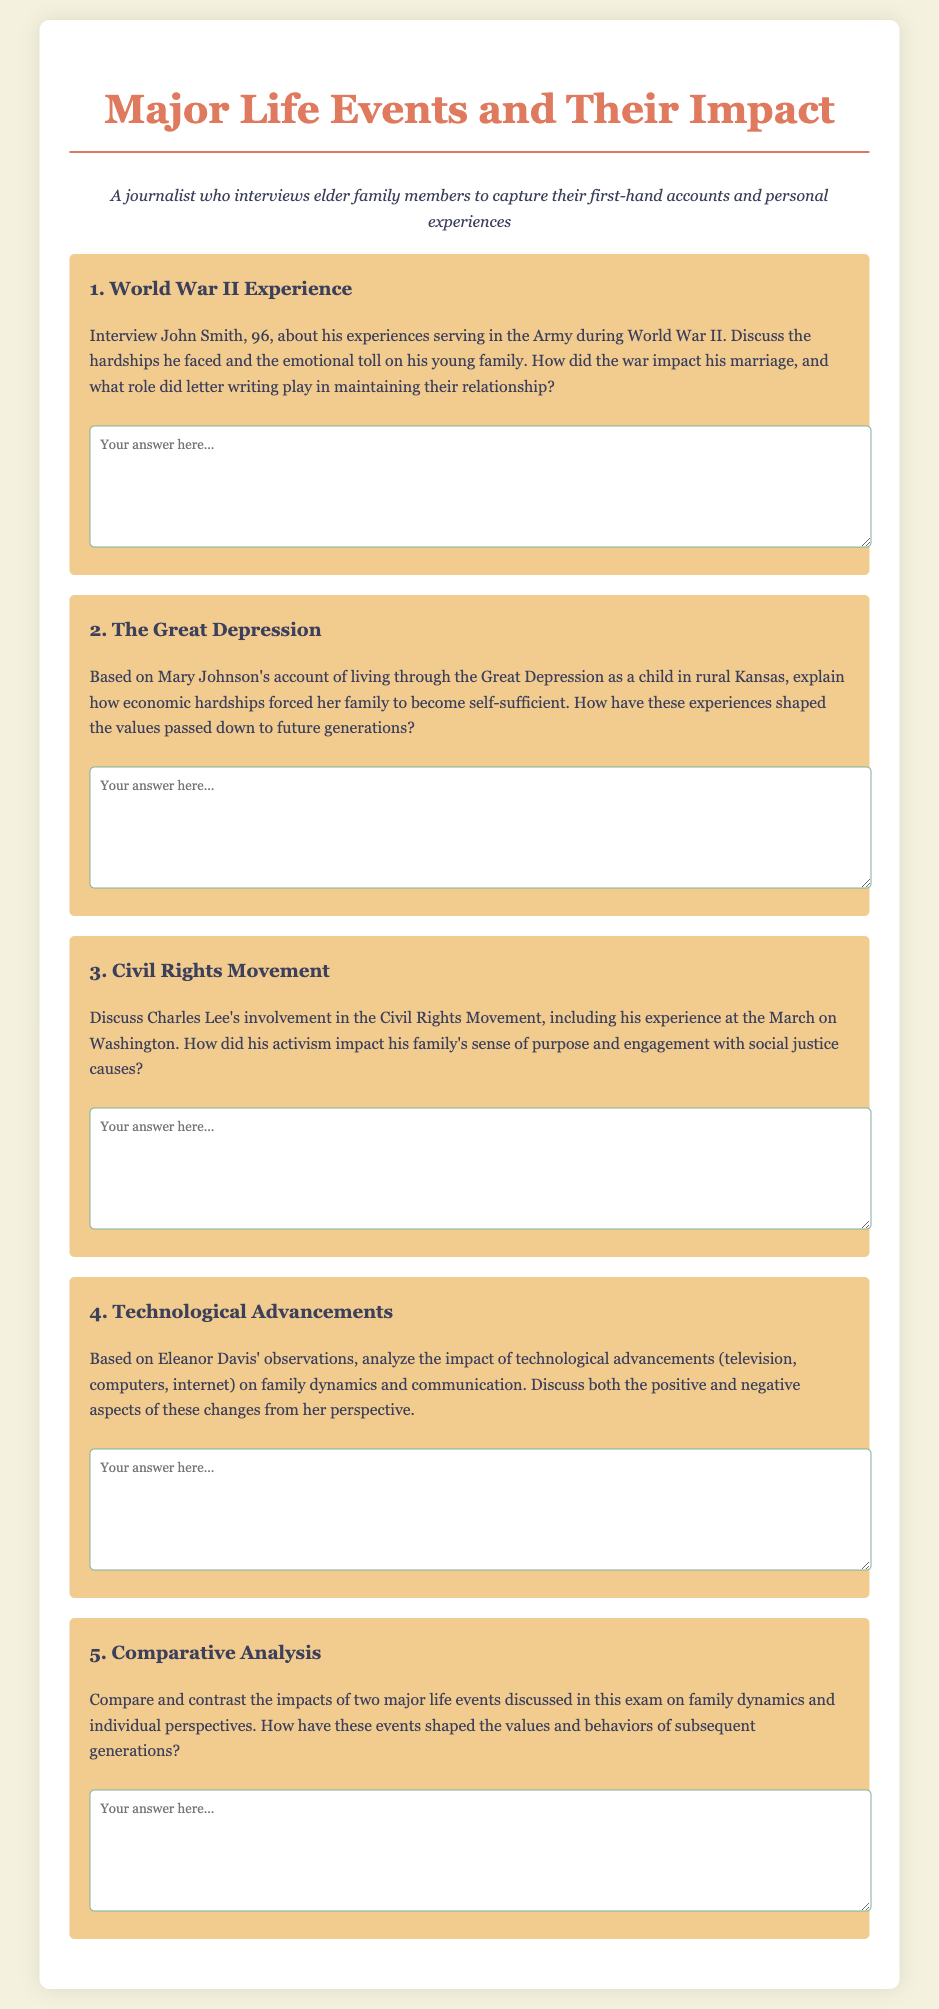What major conflict is discussed in John Smith's account? The document mentions John Smith's experiences serving in the Army during World War II.
Answer: World War II What economic crisis did Mary Johnson experience in her childhood? The document refers to Mary Johnson living through the Great Depression as a child.
Answer: The Great Depression What significant event did Charles Lee participate in related to the Civil Rights Movement? The document highlights Charles Lee's experience at the March on Washington.
Answer: March on Washington What is one technological advancement mentioned in Eleanor Davis' observations? The document lists technological advancements such as television, computers, and the internet.
Answer: Internet What type of questions are included in this midterm exam? The document outlines that this is a midterm exam focusing on major life events and their impact.
Answer: Major life events and their impact How does the exam suggest analyzing the impact on family dynamics? The exam prompts students to discuss how the major life events shaped the values and behaviors of subsequent generations.
Answer: Family dynamics and values Who is the persona described in the document? The persona in the document is a journalist who interviews elder family members.
Answer: Journalist What is the primary focus of the midterm exam content? The document emphasizes the exploration of significant life events and their impact on families.
Answer: Significant life events and their impact 